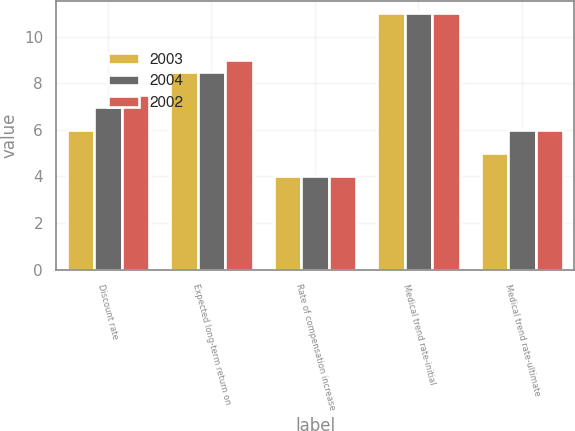<chart> <loc_0><loc_0><loc_500><loc_500><stacked_bar_chart><ecel><fcel>Discount rate<fcel>Expected long-term return on<fcel>Rate of compensation increase<fcel>Medical trend rate-initial<fcel>Medical trend rate-ultimate<nl><fcel>2003<fcel>6<fcel>8.5<fcel>4<fcel>11<fcel>5<nl><fcel>2004<fcel>7<fcel>8.5<fcel>4<fcel>11<fcel>6<nl><fcel>2002<fcel>7.5<fcel>9<fcel>4<fcel>11<fcel>6<nl></chart> 